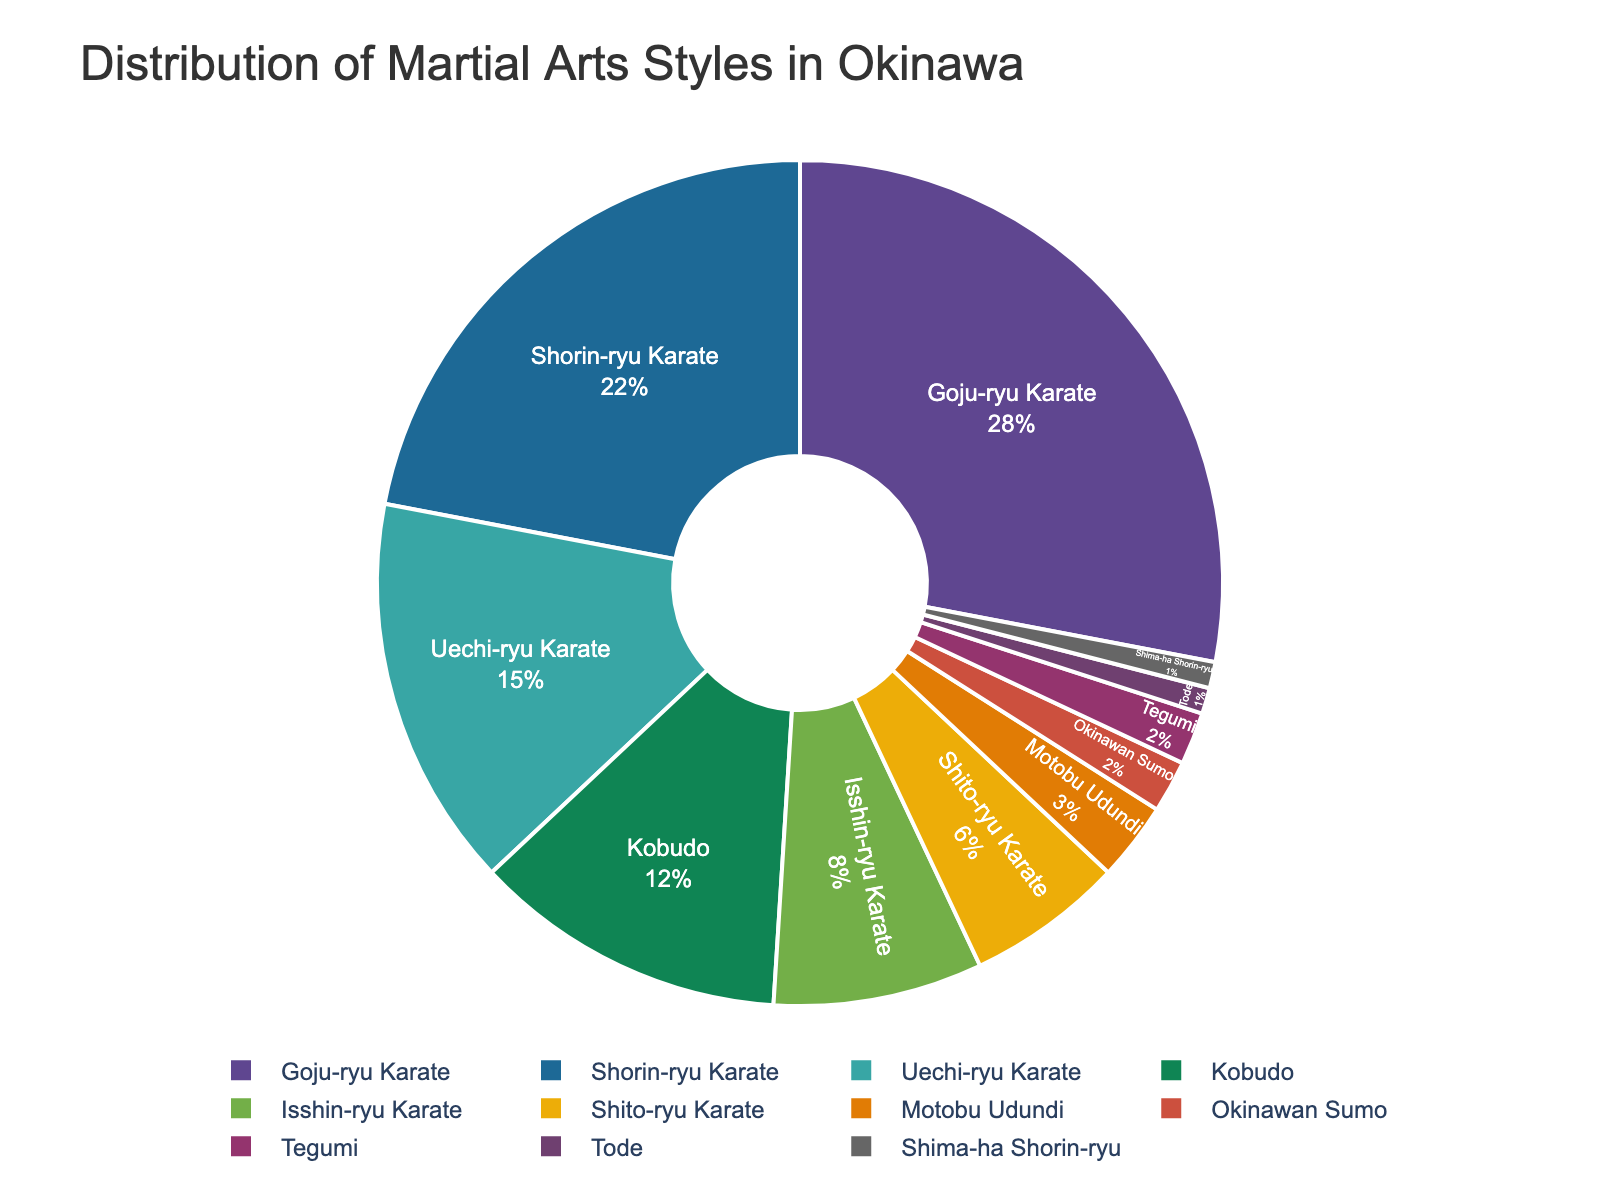Which martial arts style has the highest representation in the chart? The highest percentage is shown for "Goju-ryu Karate."
Answer: Goju-ryu Karate Which two martial arts styles collectively account for over 50% of the distribution? "Goju-ryu Karate" and "Shorin-ryu Karate" collectively account for 28% + 22% = 50%.
Answer: Goju-ryu Karate and Shorin-ryu Karate What percentage of the whole do the rarest three martial arts styles represent? "Tode," "Shima-ha Shorin-ryu," and "Okinawan Sumo" have percentages of 1%, 1%, and 2%, respectively. So, 1% + 1% + 2% = 4%.
Answer: 4% How does the percentage of "Isshin-ryu Karate" compare to "Uechi-ryu Karate"? "Isshin-ryu Karate" is 8%, while "Uechi-ryu Karate" is 15%. Since 8% < 15%, "Isshin-ryu Karate" has a lower percentage compared to "Uechi-ryu Karate."
Answer: Lower Which martial art occupies the smallest portion of the chart? The smallest percentage is for "Tode" with 1%.
Answer: Tode What is the combined percentage of all martial arts styles with less than 5% distribution? The martial arts styles with less than 5% are "Motobu Udundi" (3%), "Okinawan Sumo" (2%), "Tegumi" (2%), "Tode" (1%), and "Shima-ha Shorin-ryu" (1%). So, combined percentage is 3% + 2% + 2% + 1% + 1% = 9%.
Answer: 9% Is the total percentage of all forms of Karate more than half of the pie chart? The Karate styles are "Goju-ryu," "Shorin-ryu," "Uechi-ryu," "Isshin-ryu," and "Shito-ryu," with percentages 28%, 22%, 15%, 8%, and 6%, respectively. Summing them up: 28% + 22% + 15% + 8% + 6% = 79%, which is more than 50%.
Answer: Yes What is the difference in percentage between "Kobudo" and "Shito-ryu Karate"? "Kobudo" is 12% and "Shito-ryu Karate" is 6%. The difference is 12% - 6% = 6%.
Answer: 6% 